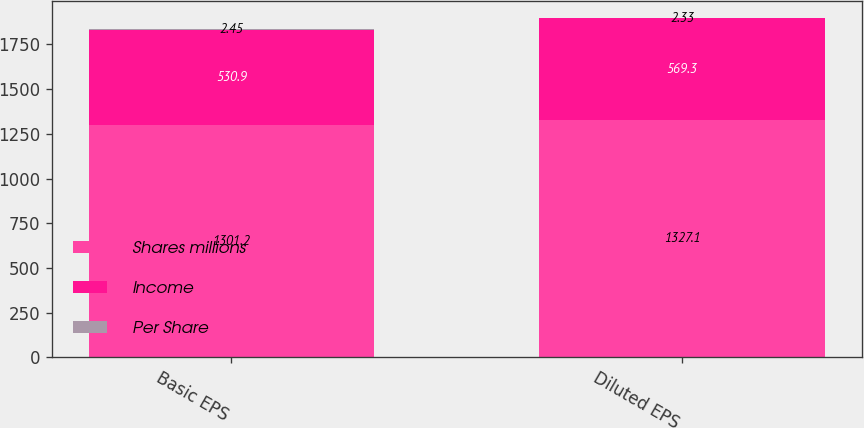Convert chart. <chart><loc_0><loc_0><loc_500><loc_500><stacked_bar_chart><ecel><fcel>Basic EPS<fcel>Diluted EPS<nl><fcel>Shares millions<fcel>1301.2<fcel>1327.1<nl><fcel>Income<fcel>530.9<fcel>569.3<nl><fcel>Per Share<fcel>2.45<fcel>2.33<nl></chart> 